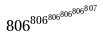Convert formula to latex. <formula><loc_0><loc_0><loc_500><loc_500>8 0 6 ^ { 8 0 6 ^ { 8 0 6 ^ { 8 0 6 ^ { 8 0 6 ^ { 8 0 7 } } } } }</formula> 